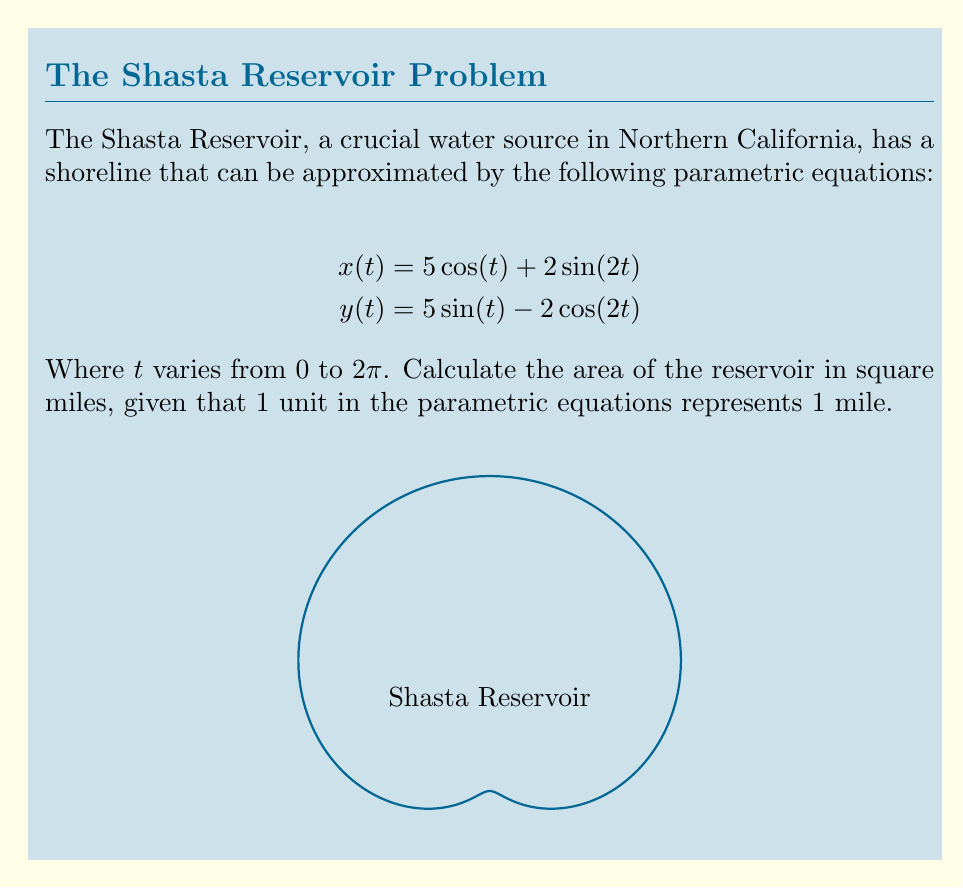Can you solve this math problem? To find the area enclosed by a parametric curve, we can use Green's theorem in the form:

$$\text{Area} = \frac{1}{2}\int_0^{2\pi} [x(t)y'(t) - y(t)x'(t)] dt$$

Let's follow these steps:

1) First, we need to find $x'(t)$ and $y'(t)$:
   $$x'(t) = -5\sin(t) + 4\cos(2t)$$
   $$y'(t) = 5\cos(t) + 4\sin(2t)$$

2) Now, let's substitute these into our area formula:
   $$\text{Area} = \frac{1}{2}\int_0^{2\pi} [(5\cos(t) + 2\sin(2t))(5\cos(t) + 4\sin(2t)) - $$
   $$(5\sin(t) - 2\cos(2t))(-5\sin(t) + 4\cos(2t))] dt$$

3) Expand this expression:
   $$\text{Area} = \frac{1}{2}\int_0^{2\pi} [25\cos^2(t) + 20\cos(t)\sin(2t) + 10\sin(2t)\cos(t) + 8\sin^2(2t) + $$
   $$25\sin^2(t) - 20\sin(t)\cos(2t) - 10\cos(2t)\sin(t) + 8\cos^2(2t)] dt$$

4) Simplify using trigonometric identities:
   $$\text{Area} = \frac{1}{2}\int_0^{2\pi} [25 + 30\sin(2t)\cos(t) - 30\sin(t)\cos(2t) + 8] dt$$
   $$= \frac{1}{2}\int_0^{2\pi} [33 + 30(\sin(3t) - \sin(t))] dt$$

5) Integrate:
   $$\text{Area} = \frac{1}{2}[33t - 10\cos(3t) + 30\cos(t)]_0^{2\pi}$$
   $$= \frac{1}{2}[33(2\pi) - 10(\cos(6\pi) - \cos(0)) + 30(\cos(2\pi) - \cos(0))]$$
   $$= \frac{1}{2}[66\pi - 10(1 - 1) + 30(1 - 1)] = 33\pi$$

Therefore, the area of the reservoir is $33\pi$ square miles.
Answer: $33\pi$ square miles 